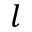Convert formula to latex. <formula><loc_0><loc_0><loc_500><loc_500>l</formula> 